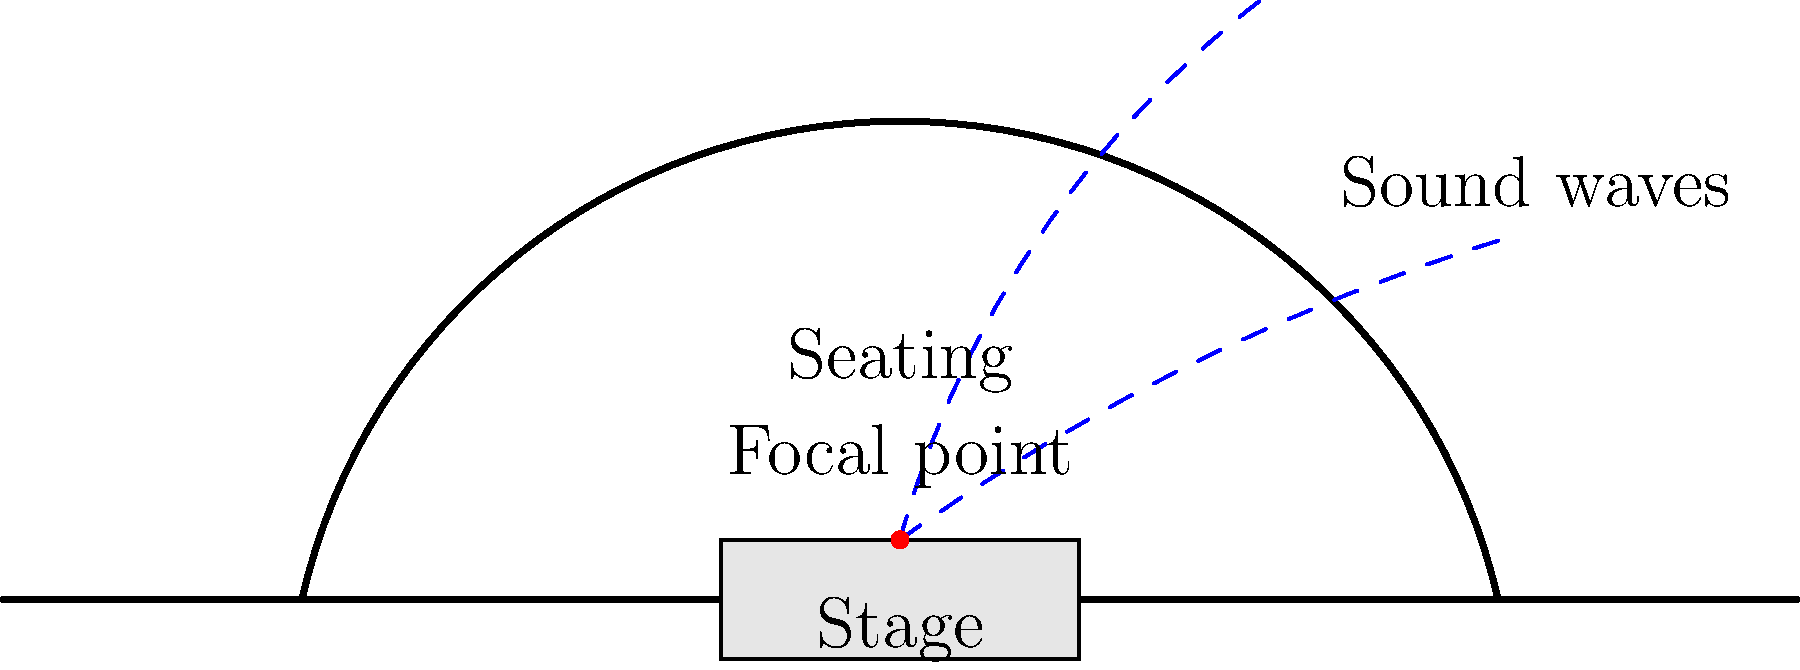As a fashion designer transitioning to film, you're working on a historical drama set in an outdoor amphitheater. To ensure optimal acoustics for the audience, which shape should the cross-section of the amphitheater seating area ideally follow, and where should the focal point of this shape be located? To optimize the acoustics of an outdoor amphitheater, we need to consider the principles of sound reflection and geometric design:

1. The ideal shape for the cross-section of the amphitheater seating area is a parabola. This shape has unique reflective properties that make it ideal for focusing sound.

2. In a parabolic shape, all sound waves originating from the focal point will be reflected parallel to the axis of symmetry. This ensures that sound is evenly distributed throughout the seating area.

3. The focal point of the parabola should be located at the center of the stage, slightly above the ground level. This placement allows for optimal sound projection from the actors to the audience.

4. The parabolic shape helps to:
   a) Minimize sound dispersion
   b) Reduce echo and reverberation
   c) Ensure consistent sound quality throughout the seating area

5. In the context of a historical drama, this design can be subtly integrated into the set design, maintaining period authenticity while providing modern acoustic benefits.

6. The stage should be positioned at the base of the parabola, with the focal point just above it. This arrangement allows for the best sound reflection to all parts of the audience.

7. Additional considerations for outdoor settings include:
   a) Wind direction and potential sound interference
   b) Background noise from the surrounding environment
   c) Materials used in construction that can affect sound reflection

By implementing a parabolic cross-section with the focal point at the center of the stage, you can create an amphitheater that not only looks historically accurate but also provides superior acoustics for your period drama.
Answer: Parabolic shape with focal point at stage center 